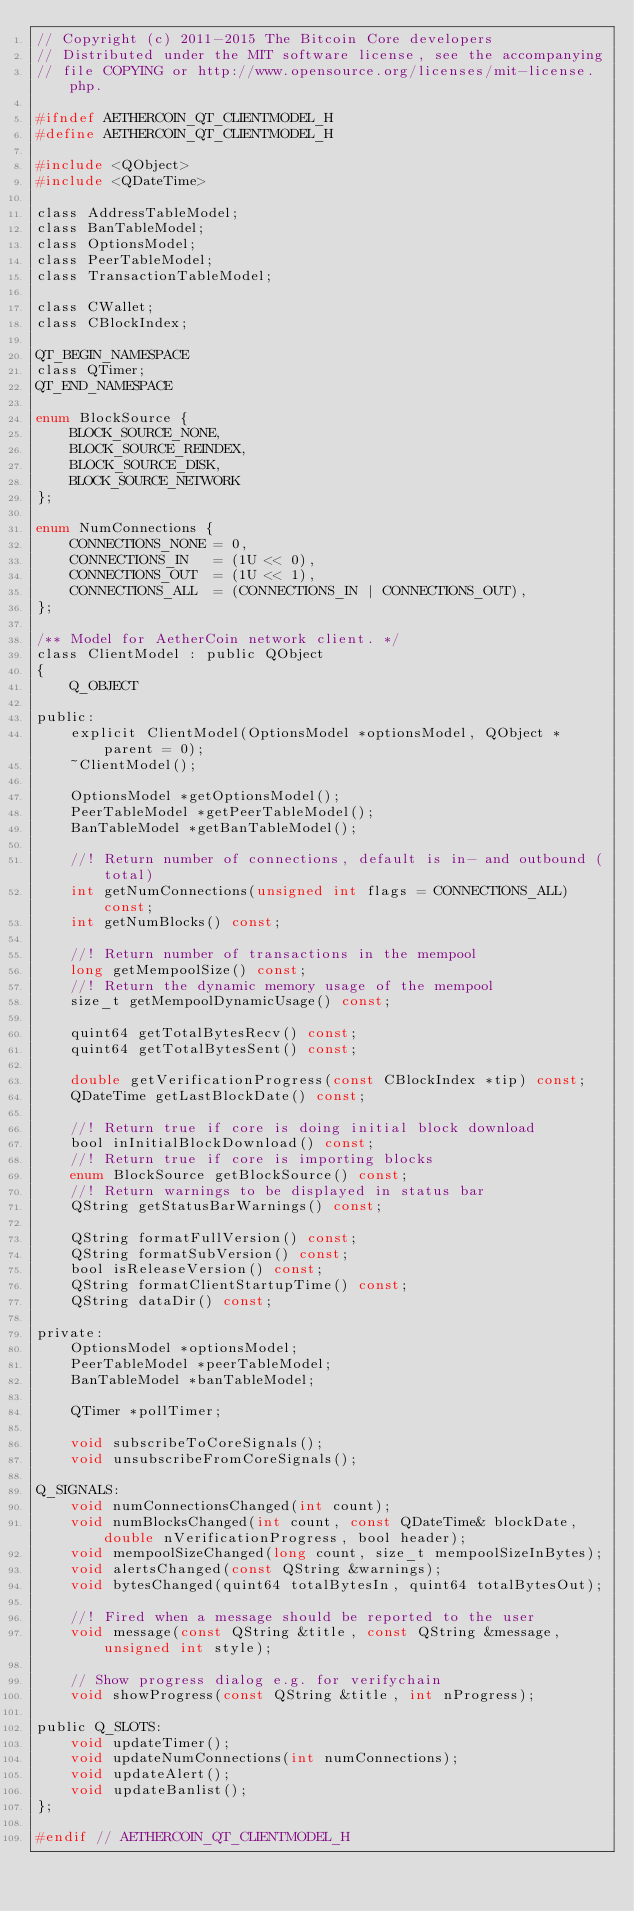Convert code to text. <code><loc_0><loc_0><loc_500><loc_500><_C_>// Copyright (c) 2011-2015 The Bitcoin Core developers
// Distributed under the MIT software license, see the accompanying
// file COPYING or http://www.opensource.org/licenses/mit-license.php.

#ifndef AETHERCOIN_QT_CLIENTMODEL_H
#define AETHERCOIN_QT_CLIENTMODEL_H

#include <QObject>
#include <QDateTime>

class AddressTableModel;
class BanTableModel;
class OptionsModel;
class PeerTableModel;
class TransactionTableModel;

class CWallet;
class CBlockIndex;

QT_BEGIN_NAMESPACE
class QTimer;
QT_END_NAMESPACE

enum BlockSource {
    BLOCK_SOURCE_NONE,
    BLOCK_SOURCE_REINDEX,
    BLOCK_SOURCE_DISK,
    BLOCK_SOURCE_NETWORK
};

enum NumConnections {
    CONNECTIONS_NONE = 0,
    CONNECTIONS_IN   = (1U << 0),
    CONNECTIONS_OUT  = (1U << 1),
    CONNECTIONS_ALL  = (CONNECTIONS_IN | CONNECTIONS_OUT),
};

/** Model for AetherCoin network client. */
class ClientModel : public QObject
{
    Q_OBJECT

public:
    explicit ClientModel(OptionsModel *optionsModel, QObject *parent = 0);
    ~ClientModel();

    OptionsModel *getOptionsModel();
    PeerTableModel *getPeerTableModel();
    BanTableModel *getBanTableModel();

    //! Return number of connections, default is in- and outbound (total)
    int getNumConnections(unsigned int flags = CONNECTIONS_ALL) const;
    int getNumBlocks() const;

    //! Return number of transactions in the mempool
    long getMempoolSize() const;
    //! Return the dynamic memory usage of the mempool
    size_t getMempoolDynamicUsage() const;
    
    quint64 getTotalBytesRecv() const;
    quint64 getTotalBytesSent() const;

    double getVerificationProgress(const CBlockIndex *tip) const;
    QDateTime getLastBlockDate() const;

    //! Return true if core is doing initial block download
    bool inInitialBlockDownload() const;
    //! Return true if core is importing blocks
    enum BlockSource getBlockSource() const;
    //! Return warnings to be displayed in status bar
    QString getStatusBarWarnings() const;

    QString formatFullVersion() const;
    QString formatSubVersion() const;
    bool isReleaseVersion() const;
    QString formatClientStartupTime() const;
    QString dataDir() const;

private:
    OptionsModel *optionsModel;
    PeerTableModel *peerTableModel;
    BanTableModel *banTableModel;

    QTimer *pollTimer;

    void subscribeToCoreSignals();
    void unsubscribeFromCoreSignals();

Q_SIGNALS:
    void numConnectionsChanged(int count);
    void numBlocksChanged(int count, const QDateTime& blockDate, double nVerificationProgress, bool header);
    void mempoolSizeChanged(long count, size_t mempoolSizeInBytes);
    void alertsChanged(const QString &warnings);
    void bytesChanged(quint64 totalBytesIn, quint64 totalBytesOut);

    //! Fired when a message should be reported to the user
    void message(const QString &title, const QString &message, unsigned int style);

    // Show progress dialog e.g. for verifychain
    void showProgress(const QString &title, int nProgress);

public Q_SLOTS:
    void updateTimer();
    void updateNumConnections(int numConnections);
    void updateAlert();
    void updateBanlist();
};

#endif // AETHERCOIN_QT_CLIENTMODEL_H
</code> 